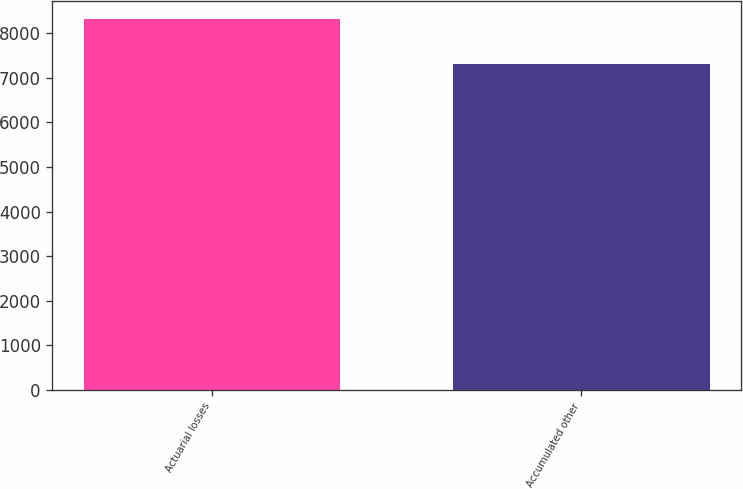Convert chart to OTSL. <chart><loc_0><loc_0><loc_500><loc_500><bar_chart><fcel>Actuarial losses<fcel>Accumulated other<nl><fcel>8321<fcel>7321<nl></chart> 